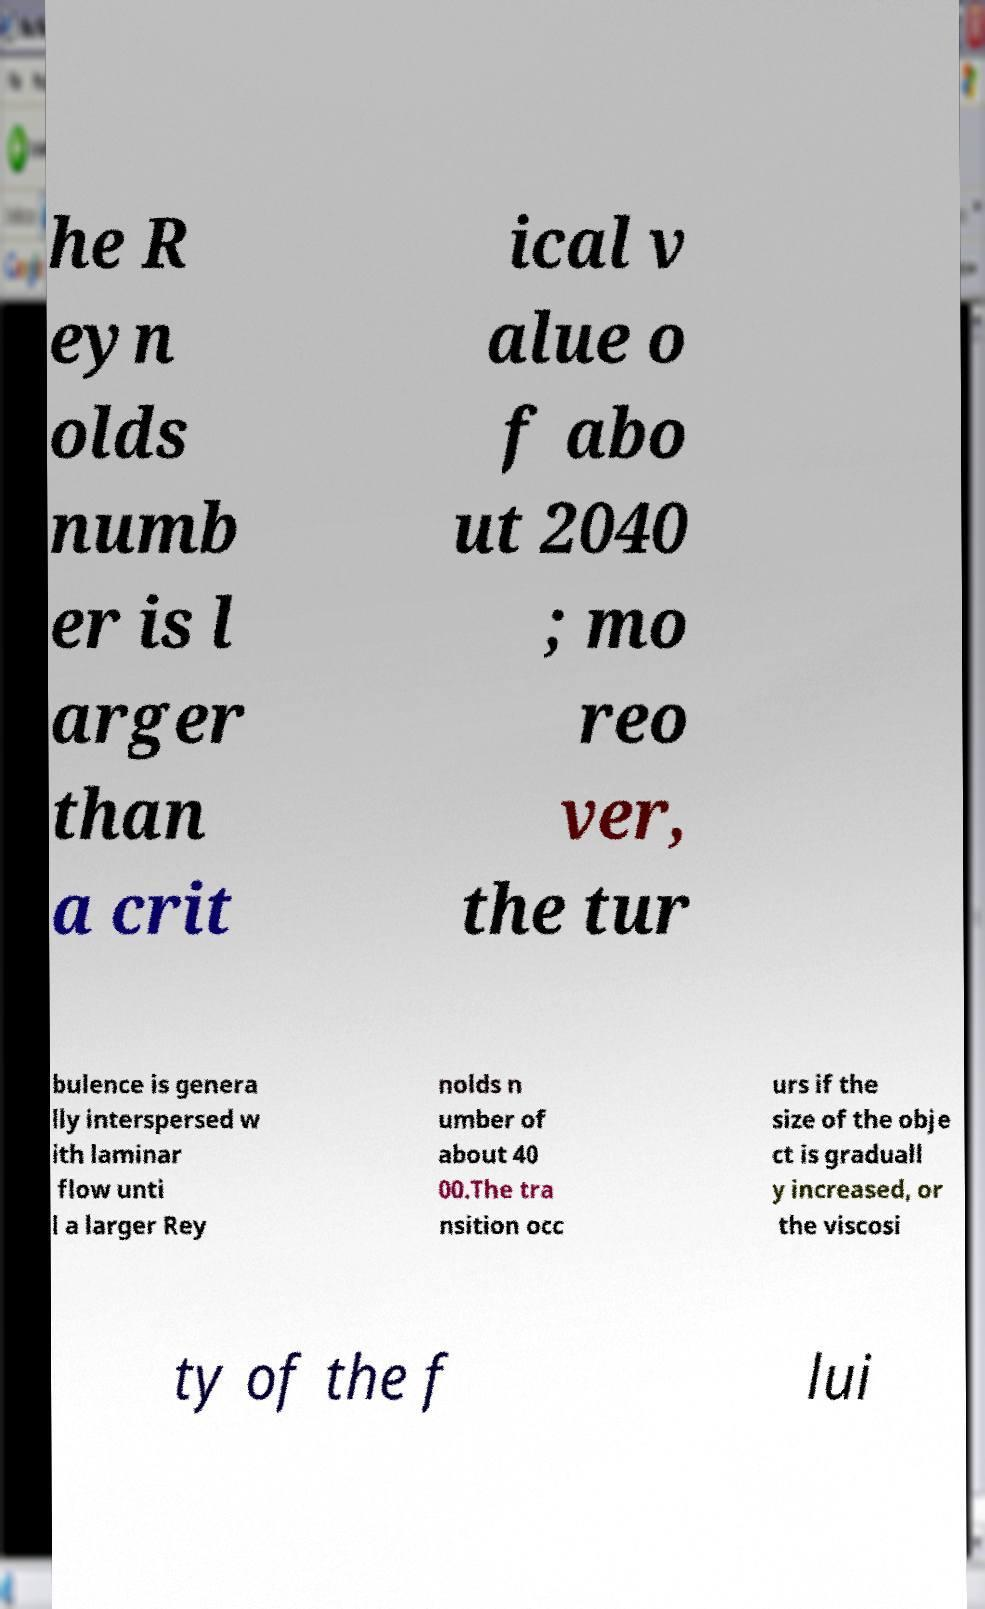Can you read and provide the text displayed in the image?This photo seems to have some interesting text. Can you extract and type it out for me? he R eyn olds numb er is l arger than a crit ical v alue o f abo ut 2040 ; mo reo ver, the tur bulence is genera lly interspersed w ith laminar flow unti l a larger Rey nolds n umber of about 40 00.The tra nsition occ urs if the size of the obje ct is graduall y increased, or the viscosi ty of the f lui 